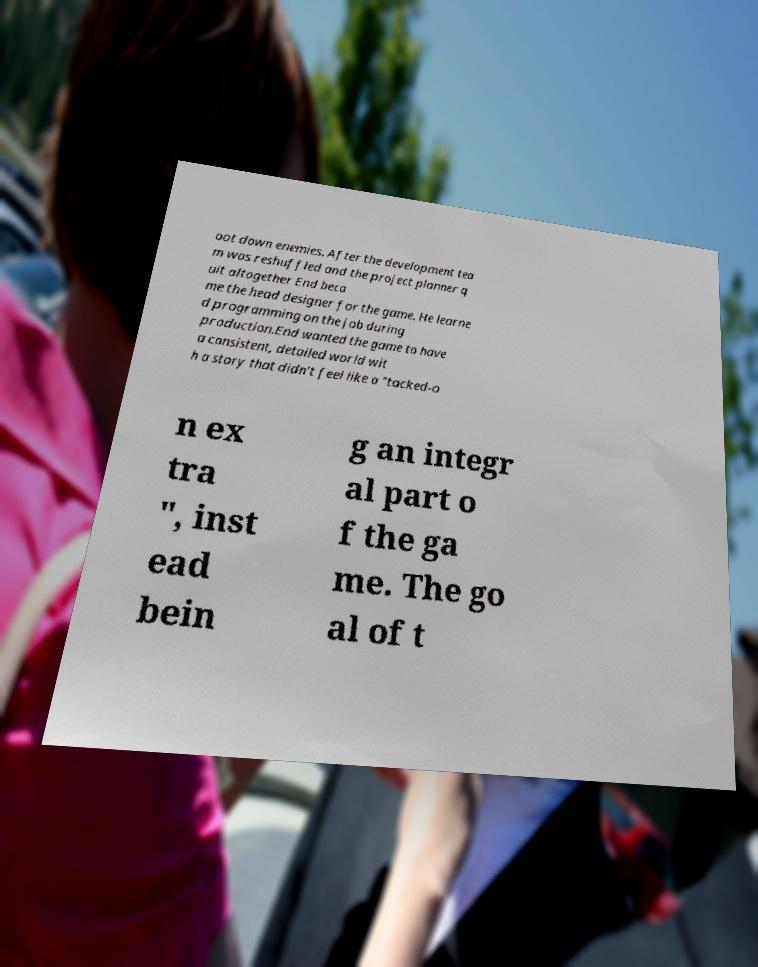Please identify and transcribe the text found in this image. oot down enemies. After the development tea m was reshuffled and the project planner q uit altogether End beca me the head designer for the game. He learne d programming on the job during production.End wanted the game to have a consistent, detailed world wit h a story that didn't feel like a "tacked-o n ex tra ", inst ead bein g an integr al part o f the ga me. The go al of t 